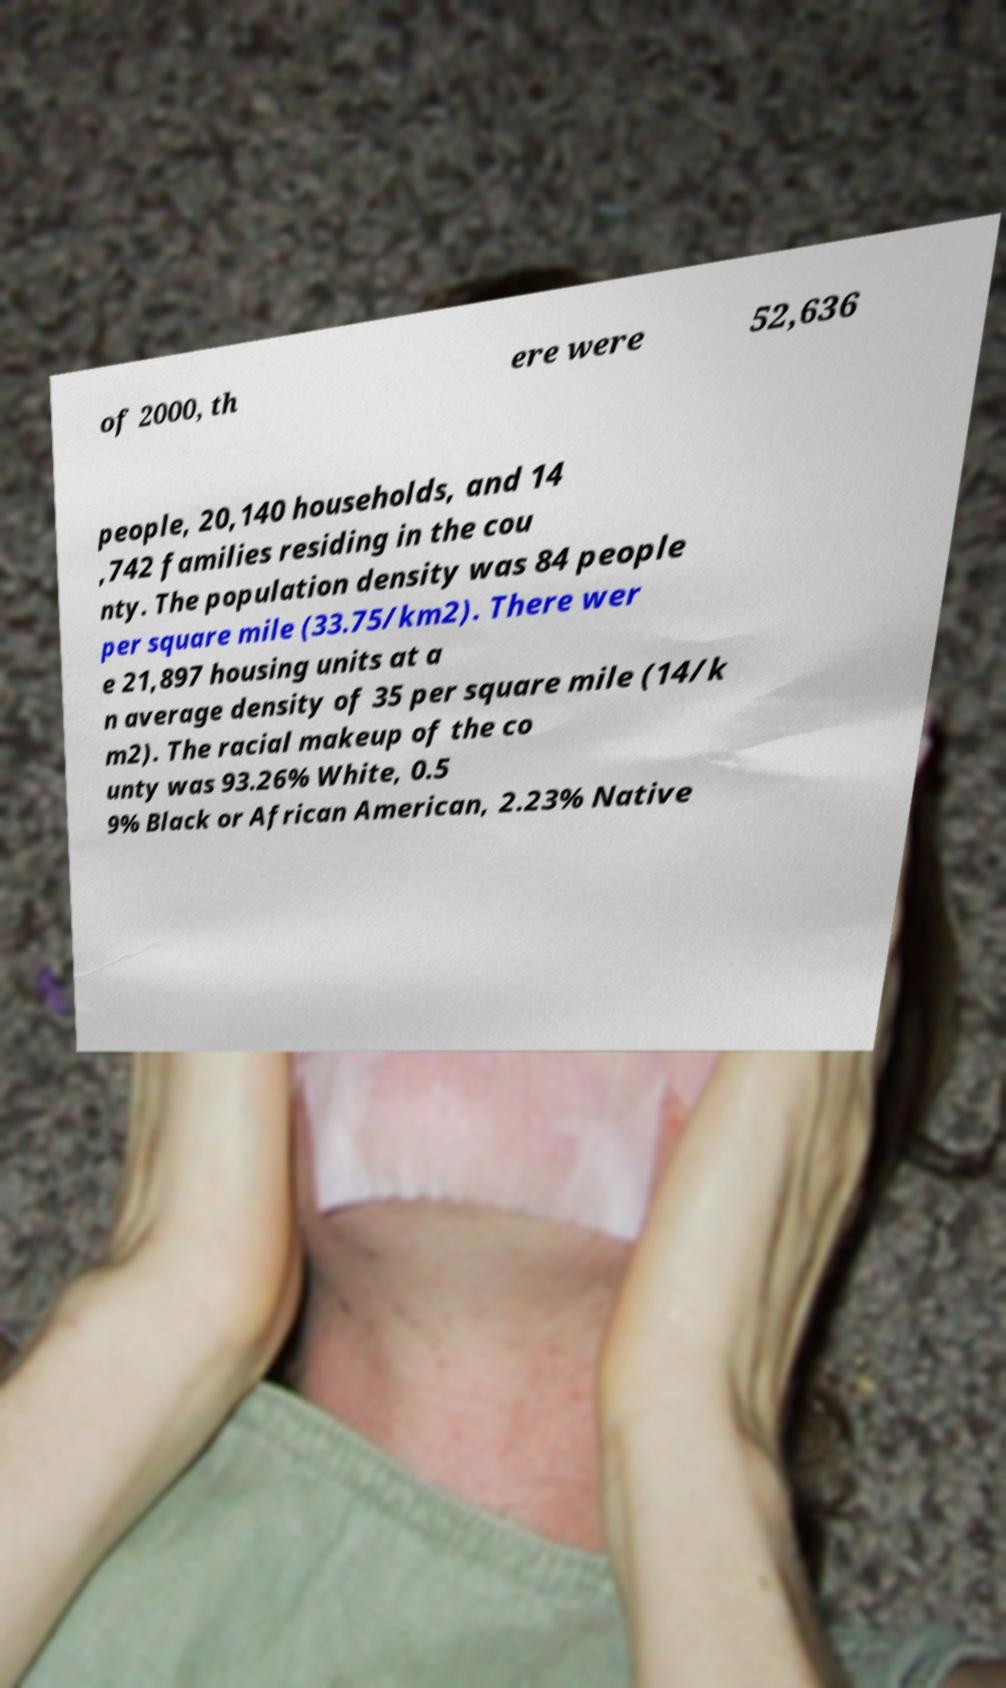Can you accurately transcribe the text from the provided image for me? of 2000, th ere were 52,636 people, 20,140 households, and 14 ,742 families residing in the cou nty. The population density was 84 people per square mile (33.75/km2). There wer e 21,897 housing units at a n average density of 35 per square mile (14/k m2). The racial makeup of the co unty was 93.26% White, 0.5 9% Black or African American, 2.23% Native 